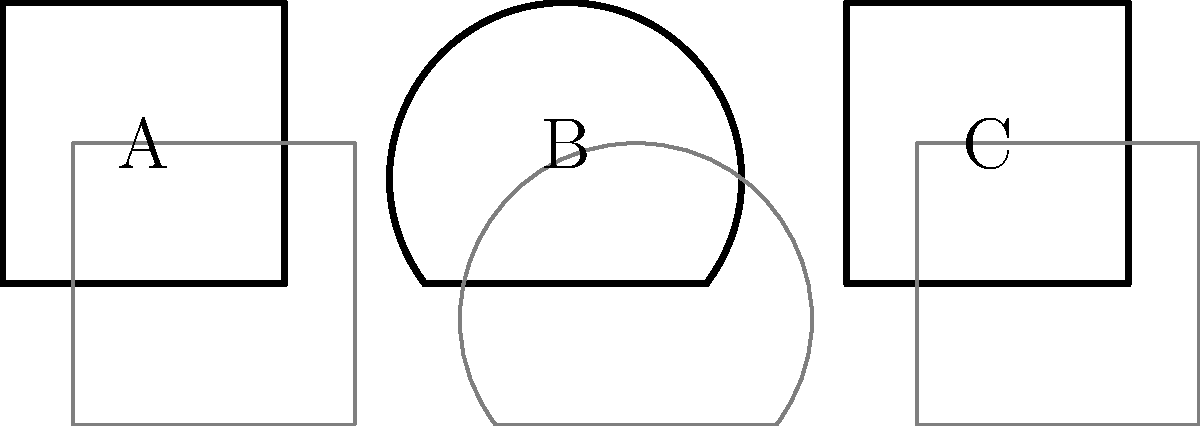In this film noir-inspired scene, three objects cast shadows. Which object's shadow most closely resembles the iconic "Venetian blind" effect often used in 1960s crime thrillers? To answer this question, we need to analyze the shadows cast by each object:

1. Object A (Square):
   - Casts a regular square shadow
   - Does not resemble Venetian blinds

2. Object B (Triangle):
   - Casts a triangular shadow
   - Does not resemble Venetian blinds

3. Object C (Rectangle):
   - Casts a rectangular shadow
   - The elongated shape of the rectangle is similar to the effect of light passing through Venetian blinds
   - In film noir, this effect was often created by using actual blinds or placing a slatted screen in front of a light source

The "Venetian blind" effect in film noir is characterized by parallel lines of light and shadow, often projected onto walls or across characters' faces. This effect creates a sense of mystery, tension, and visual interest.

Object C's rectangular shape and its shadow most closely resemble this effect, as it could represent the alternating light and dark stripes created by light passing through partially closed Venetian blinds.
Answer: C 